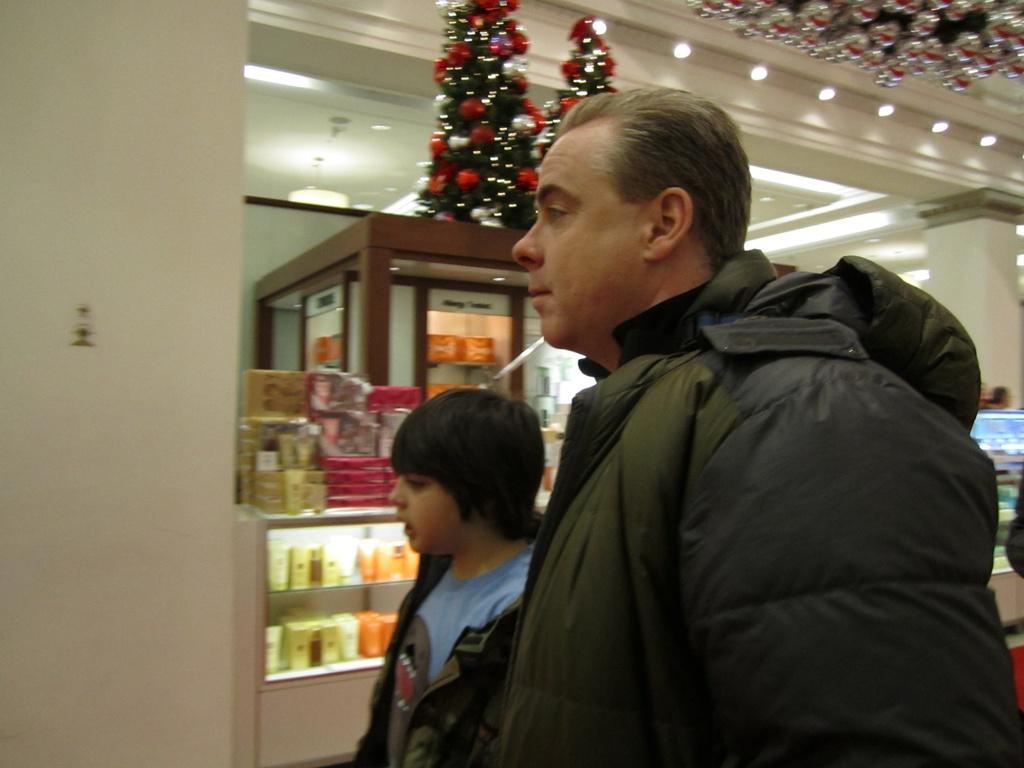Describe this image in one or two sentences. There are two persons standing and we can see wall. On the background we can see some objects in glass racks. On top we can see lights and Christmas trees. 